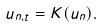Convert formula to latex. <formula><loc_0><loc_0><loc_500><loc_500>u _ { n , t } = K ( u _ { n } ) .</formula> 